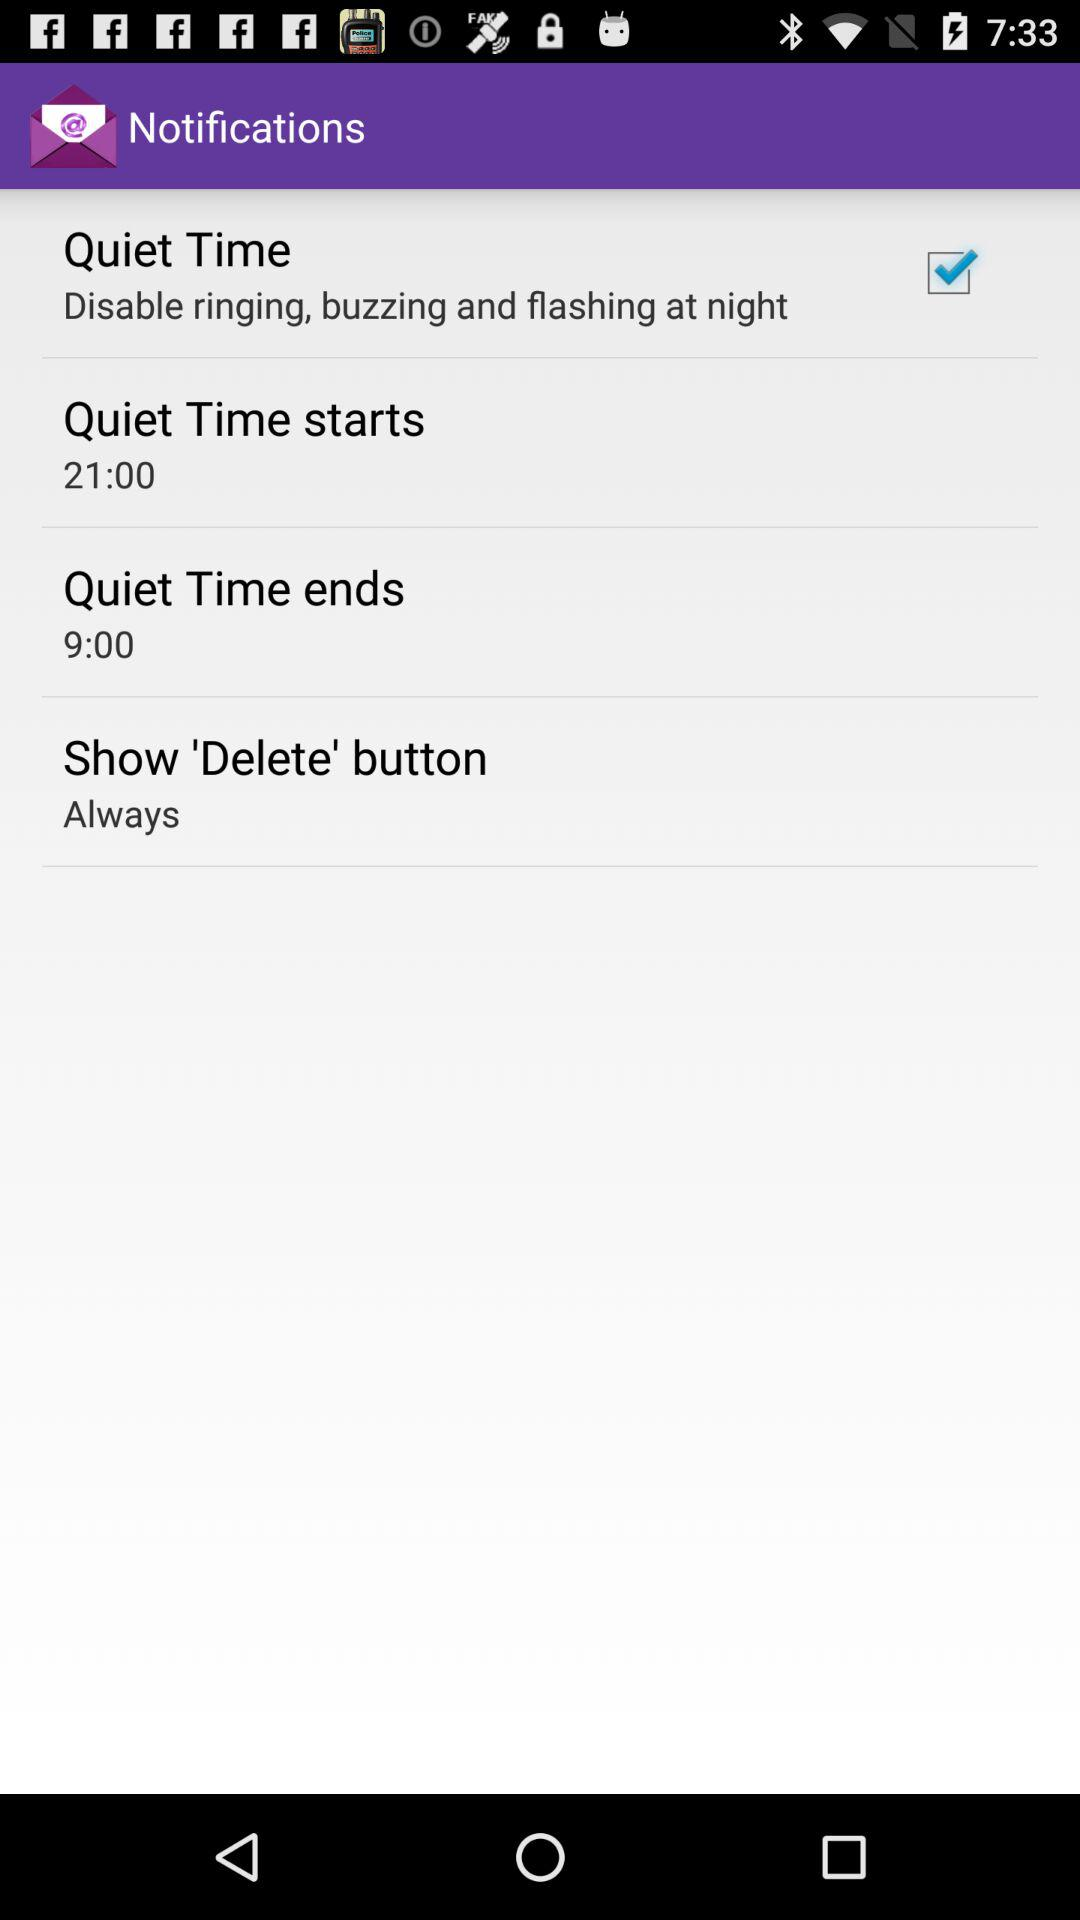What is the end time? The end time is 9:00. 